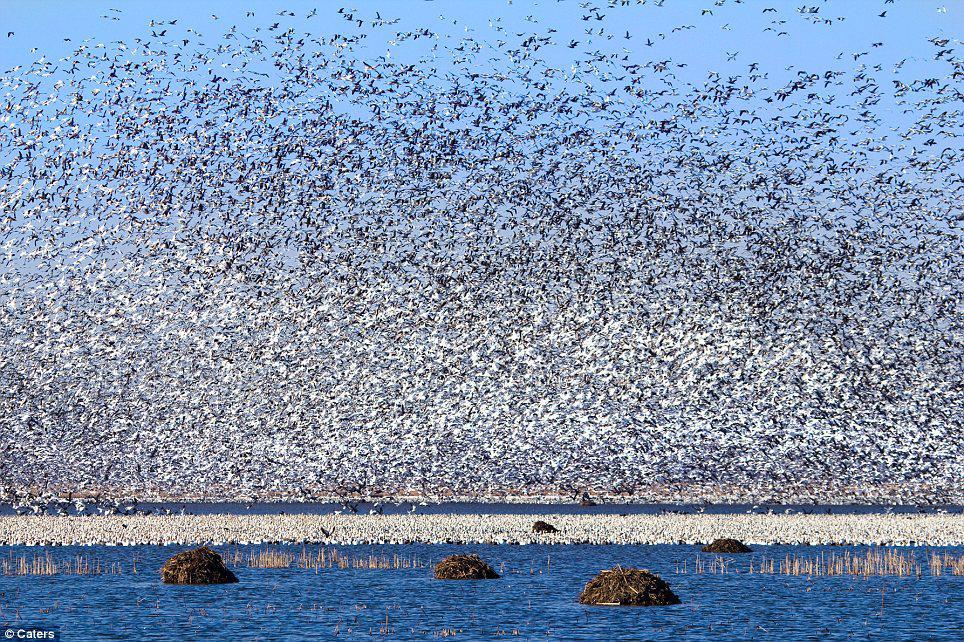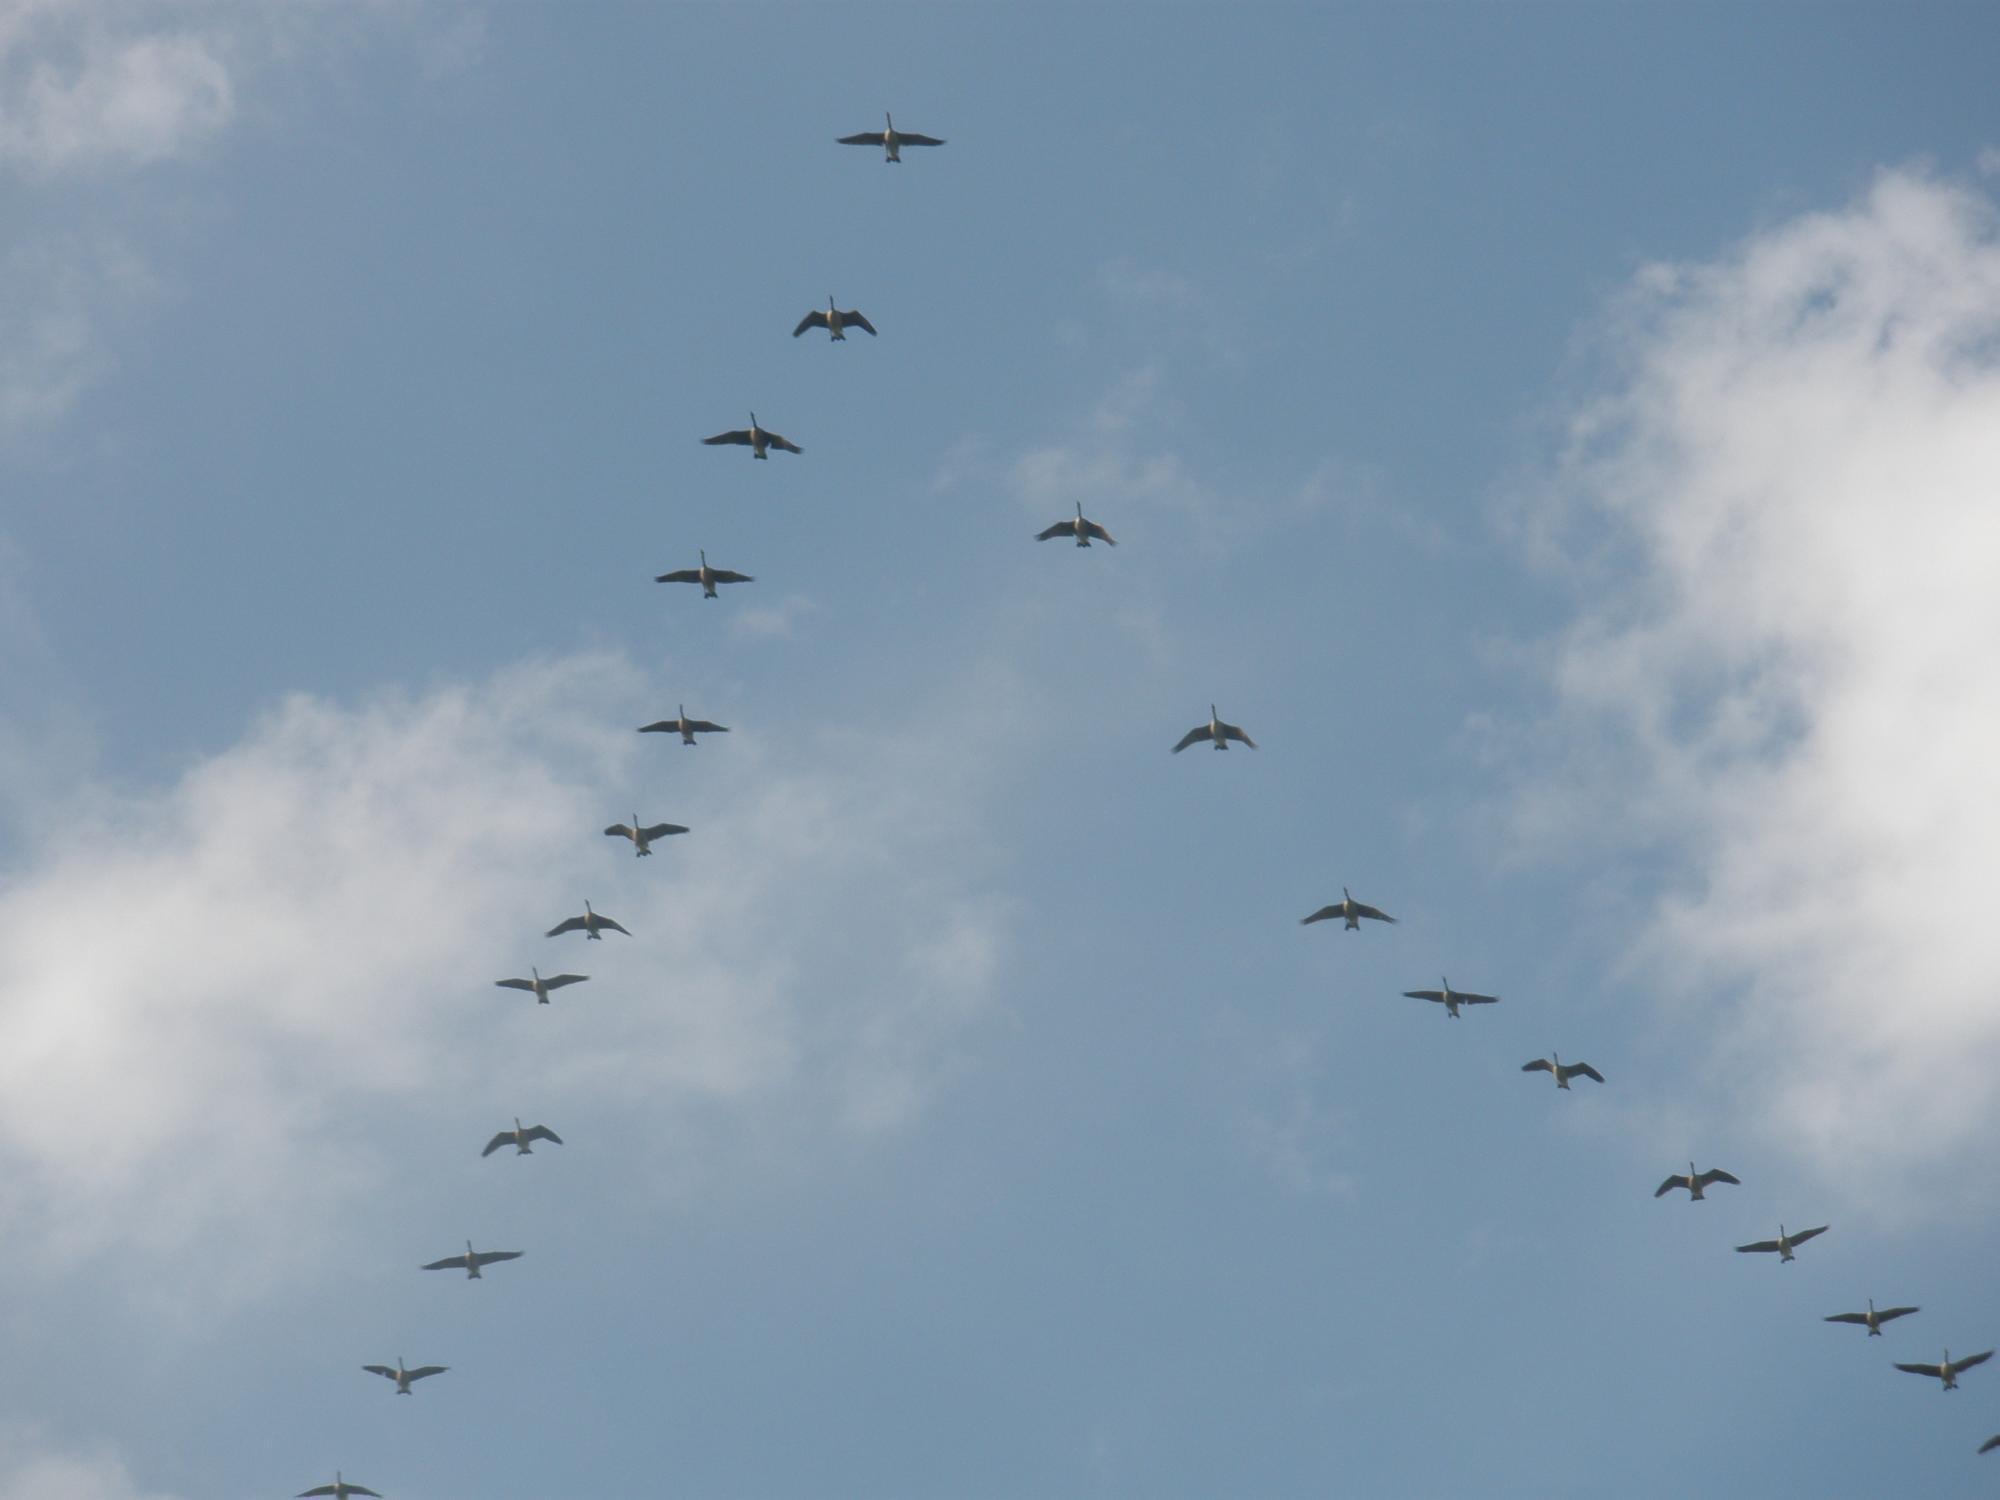The first image is the image on the left, the second image is the image on the right. For the images displayed, is the sentence "There are no more than 22 birds in one of the images." factually correct? Answer yes or no. Yes. The first image is the image on the left, the second image is the image on the right. Assess this claim about the two images: "In one image, only birds and sky are visible.". Correct or not? Answer yes or no. Yes. 